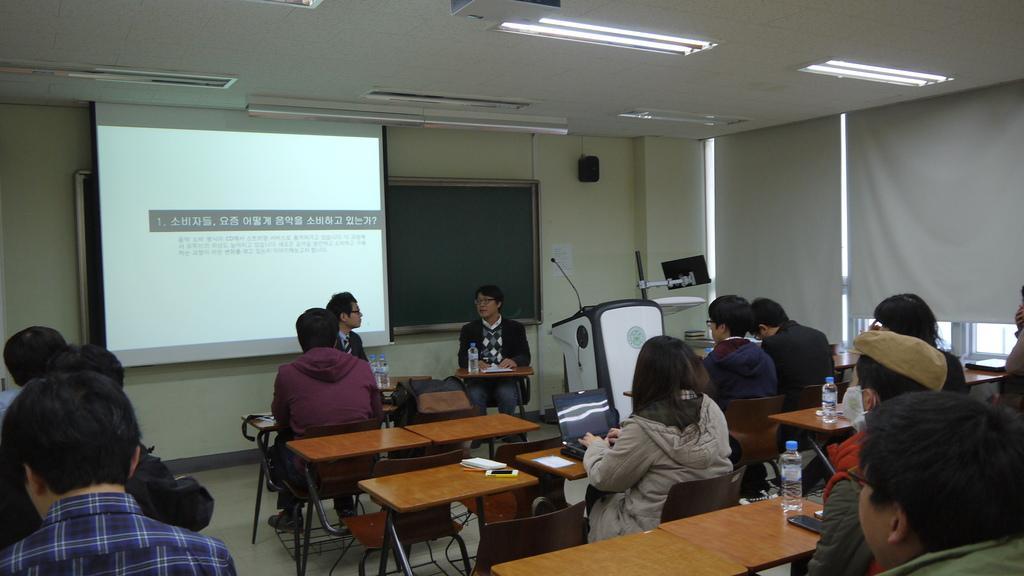Could you give a brief overview of what you see in this image? This picture describes about group of people they are all seated on the chair, in front of them we can find water bottle, mobile, book, laptop on the table, and also we can find projector screen, podium, microphone and window blinds. 